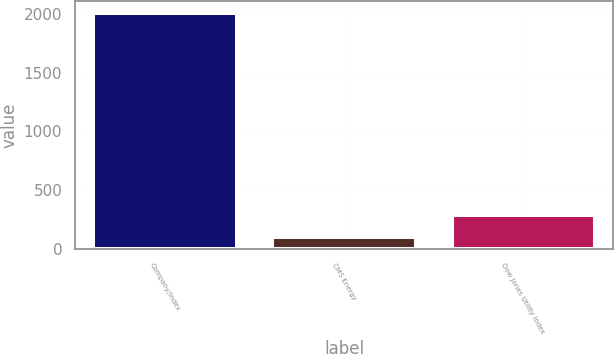<chart> <loc_0><loc_0><loc_500><loc_500><bar_chart><fcel>Company/Index<fcel>CMS Energy<fcel>Dow Jones Utility Index<nl><fcel>2012<fcel>100<fcel>291.2<nl></chart> 